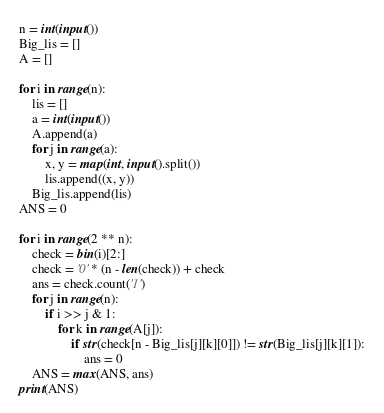<code> <loc_0><loc_0><loc_500><loc_500><_Python_>n = int(input())
Big_lis = []
A = []

for i in range(n):
    lis = []
    a = int(input())
    A.append(a)
    for j in range(a):
        x, y = map(int, input().split())
        lis.append((x, y))
    Big_lis.append(lis)
ANS = 0

for i in range(2 ** n):
    check = bin(i)[2:]
    check = '0' * (n - len(check)) + check
    ans = check.count('1')
    for j in range(n):
        if i >> j & 1:
            for k in range(A[j]):
                if str(check[n - Big_lis[j][k][0]]) != str(Big_lis[j][k][1]):
                    ans = 0
    ANS = max(ANS, ans)
print(ANS)</code> 